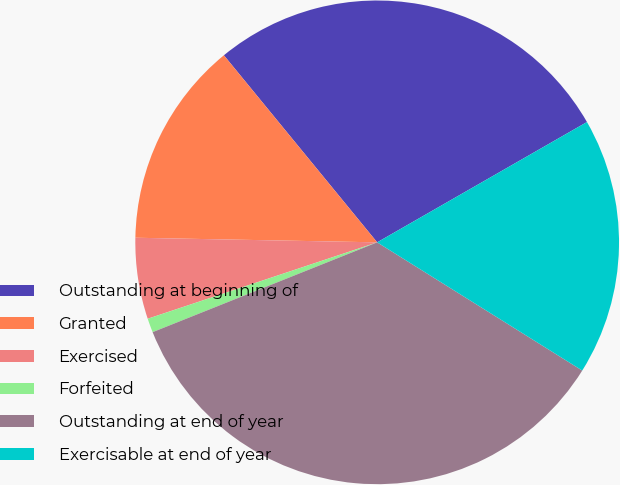Convert chart. <chart><loc_0><loc_0><loc_500><loc_500><pie_chart><fcel>Outstanding at beginning of<fcel>Granted<fcel>Exercised<fcel>Forfeited<fcel>Outstanding at end of year<fcel>Exercisable at end of year<nl><fcel>27.64%<fcel>13.77%<fcel>5.42%<fcel>0.94%<fcel>35.05%<fcel>17.18%<nl></chart> 